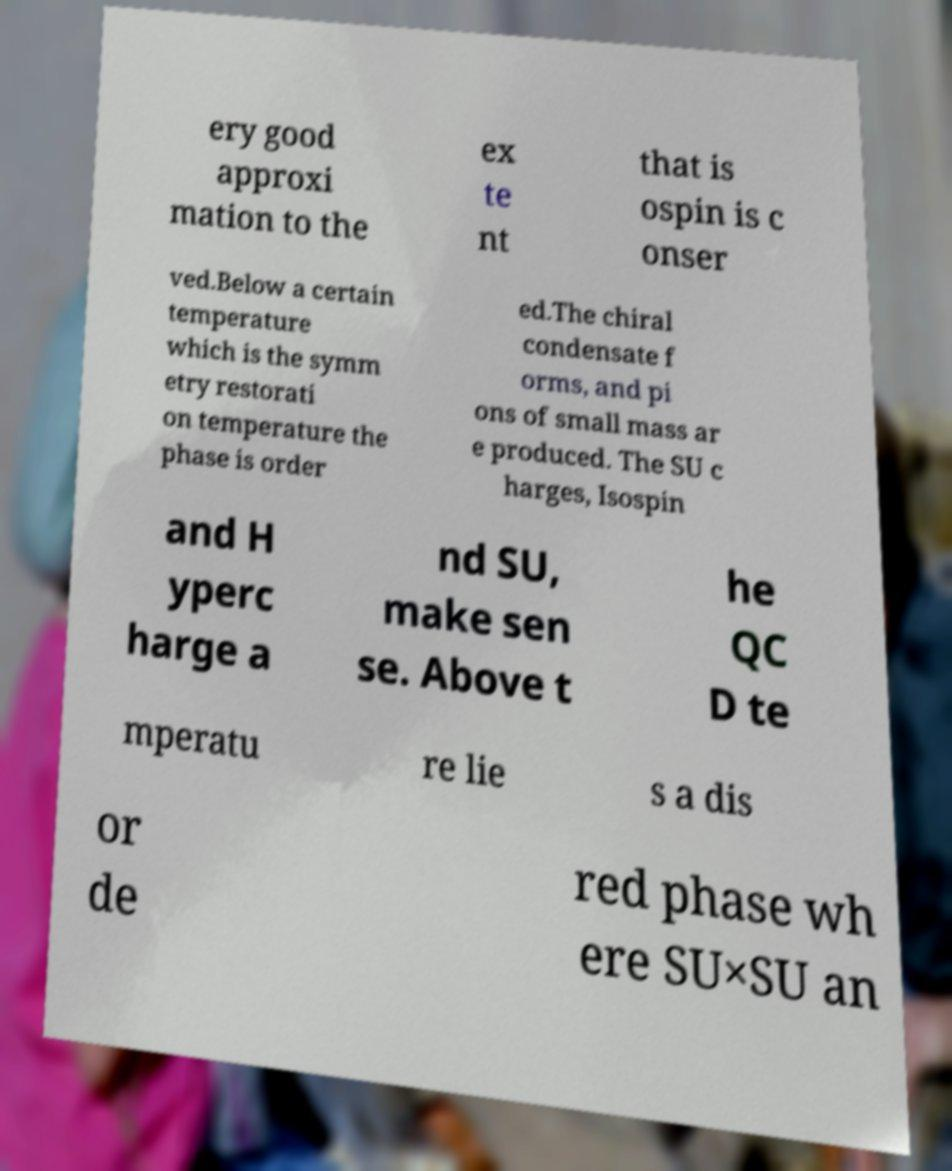What messages or text are displayed in this image? I need them in a readable, typed format. ery good approxi mation to the ex te nt that is ospin is c onser ved.Below a certain temperature which is the symm etry restorati on temperature the phase is order ed.The chiral condensate f orms, and pi ons of small mass ar e produced. The SU c harges, Isospin and H yperc harge a nd SU, make sen se. Above t he QC D te mperatu re lie s a dis or de red phase wh ere SU×SU an 